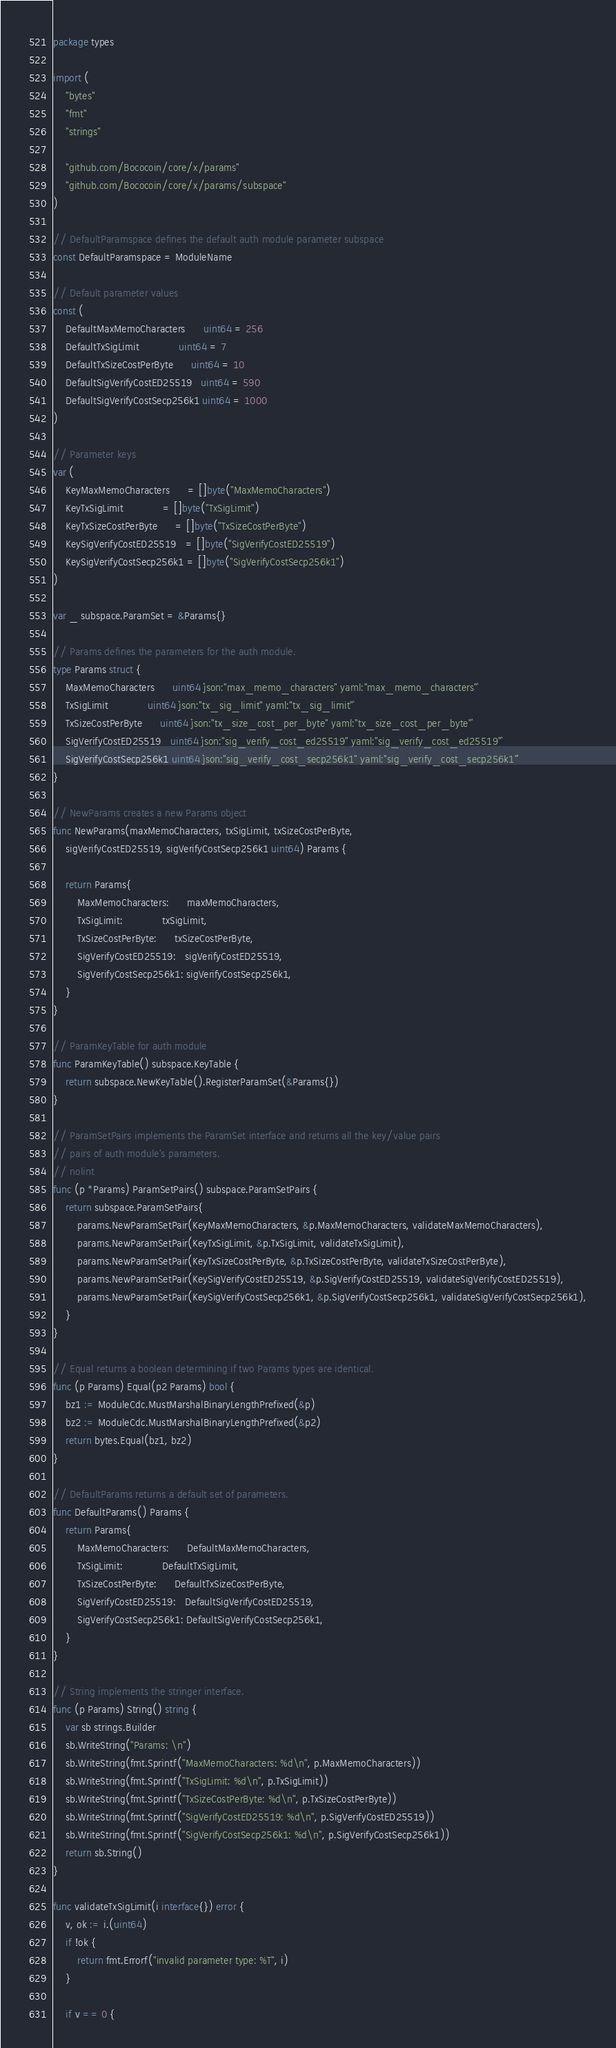<code> <loc_0><loc_0><loc_500><loc_500><_Go_>package types

import (
	"bytes"
	"fmt"
	"strings"

	"github.com/Bococoin/core/x/params"
	"github.com/Bococoin/core/x/params/subspace"
)

// DefaultParamspace defines the default auth module parameter subspace
const DefaultParamspace = ModuleName

// Default parameter values
const (
	DefaultMaxMemoCharacters      uint64 = 256
	DefaultTxSigLimit             uint64 = 7
	DefaultTxSizeCostPerByte      uint64 = 10
	DefaultSigVerifyCostED25519   uint64 = 590
	DefaultSigVerifyCostSecp256k1 uint64 = 1000
)

// Parameter keys
var (
	KeyMaxMemoCharacters      = []byte("MaxMemoCharacters")
	KeyTxSigLimit             = []byte("TxSigLimit")
	KeyTxSizeCostPerByte      = []byte("TxSizeCostPerByte")
	KeySigVerifyCostED25519   = []byte("SigVerifyCostED25519")
	KeySigVerifyCostSecp256k1 = []byte("SigVerifyCostSecp256k1")
)

var _ subspace.ParamSet = &Params{}

// Params defines the parameters for the auth module.
type Params struct {
	MaxMemoCharacters      uint64 `json:"max_memo_characters" yaml:"max_memo_characters"`
	TxSigLimit             uint64 `json:"tx_sig_limit" yaml:"tx_sig_limit"`
	TxSizeCostPerByte      uint64 `json:"tx_size_cost_per_byte" yaml:"tx_size_cost_per_byte"`
	SigVerifyCostED25519   uint64 `json:"sig_verify_cost_ed25519" yaml:"sig_verify_cost_ed25519"`
	SigVerifyCostSecp256k1 uint64 `json:"sig_verify_cost_secp256k1" yaml:"sig_verify_cost_secp256k1"`
}

// NewParams creates a new Params object
func NewParams(maxMemoCharacters, txSigLimit, txSizeCostPerByte,
	sigVerifyCostED25519, sigVerifyCostSecp256k1 uint64) Params {

	return Params{
		MaxMemoCharacters:      maxMemoCharacters,
		TxSigLimit:             txSigLimit,
		TxSizeCostPerByte:      txSizeCostPerByte,
		SigVerifyCostED25519:   sigVerifyCostED25519,
		SigVerifyCostSecp256k1: sigVerifyCostSecp256k1,
	}
}

// ParamKeyTable for auth module
func ParamKeyTable() subspace.KeyTable {
	return subspace.NewKeyTable().RegisterParamSet(&Params{})
}

// ParamSetPairs implements the ParamSet interface and returns all the key/value pairs
// pairs of auth module's parameters.
// nolint
func (p *Params) ParamSetPairs() subspace.ParamSetPairs {
	return subspace.ParamSetPairs{
		params.NewParamSetPair(KeyMaxMemoCharacters, &p.MaxMemoCharacters, validateMaxMemoCharacters),
		params.NewParamSetPair(KeyTxSigLimit, &p.TxSigLimit, validateTxSigLimit),
		params.NewParamSetPair(KeyTxSizeCostPerByte, &p.TxSizeCostPerByte, validateTxSizeCostPerByte),
		params.NewParamSetPair(KeySigVerifyCostED25519, &p.SigVerifyCostED25519, validateSigVerifyCostED25519),
		params.NewParamSetPair(KeySigVerifyCostSecp256k1, &p.SigVerifyCostSecp256k1, validateSigVerifyCostSecp256k1),
	}
}

// Equal returns a boolean determining if two Params types are identical.
func (p Params) Equal(p2 Params) bool {
	bz1 := ModuleCdc.MustMarshalBinaryLengthPrefixed(&p)
	bz2 := ModuleCdc.MustMarshalBinaryLengthPrefixed(&p2)
	return bytes.Equal(bz1, bz2)
}

// DefaultParams returns a default set of parameters.
func DefaultParams() Params {
	return Params{
		MaxMemoCharacters:      DefaultMaxMemoCharacters,
		TxSigLimit:             DefaultTxSigLimit,
		TxSizeCostPerByte:      DefaultTxSizeCostPerByte,
		SigVerifyCostED25519:   DefaultSigVerifyCostED25519,
		SigVerifyCostSecp256k1: DefaultSigVerifyCostSecp256k1,
	}
}

// String implements the stringer interface.
func (p Params) String() string {
	var sb strings.Builder
	sb.WriteString("Params: \n")
	sb.WriteString(fmt.Sprintf("MaxMemoCharacters: %d\n", p.MaxMemoCharacters))
	sb.WriteString(fmt.Sprintf("TxSigLimit: %d\n", p.TxSigLimit))
	sb.WriteString(fmt.Sprintf("TxSizeCostPerByte: %d\n", p.TxSizeCostPerByte))
	sb.WriteString(fmt.Sprintf("SigVerifyCostED25519: %d\n", p.SigVerifyCostED25519))
	sb.WriteString(fmt.Sprintf("SigVerifyCostSecp256k1: %d\n", p.SigVerifyCostSecp256k1))
	return sb.String()
}

func validateTxSigLimit(i interface{}) error {
	v, ok := i.(uint64)
	if !ok {
		return fmt.Errorf("invalid parameter type: %T", i)
	}

	if v == 0 {</code> 